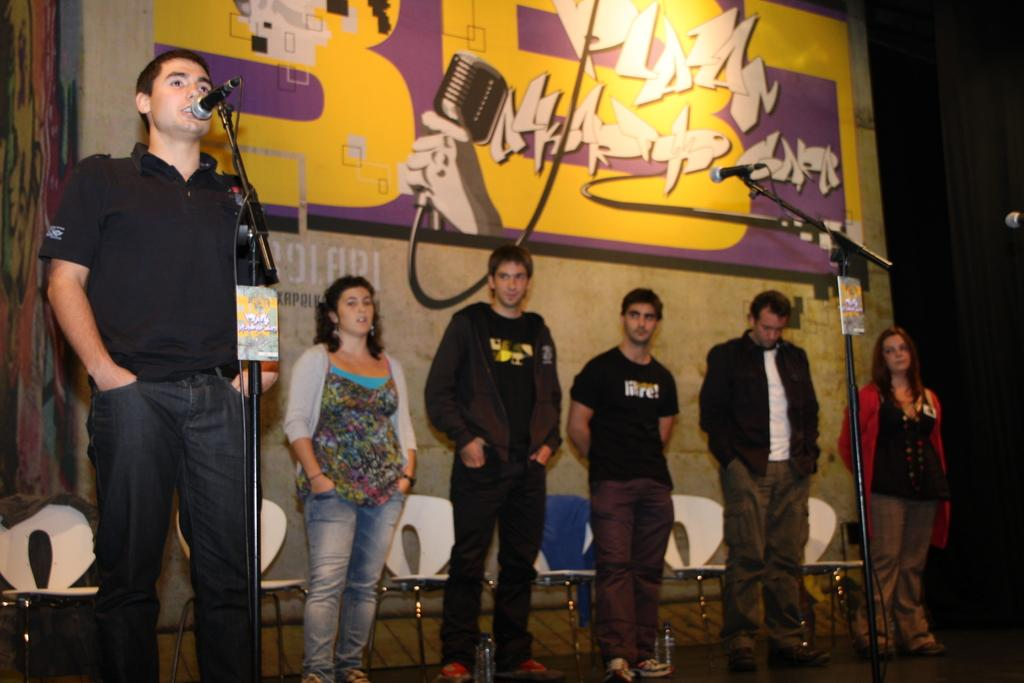What is the person in the image doing? The person is standing in front of a mic. Are there any other people in the image? Yes, there are other people nearby. What can be seen in the background of the image? There is a banner visible in the background. How many mics are present in the image? There is another mic present in the image. What type of chicken is being detailed in the image? There is no chicken present in the image, and no detailing is taking place. 